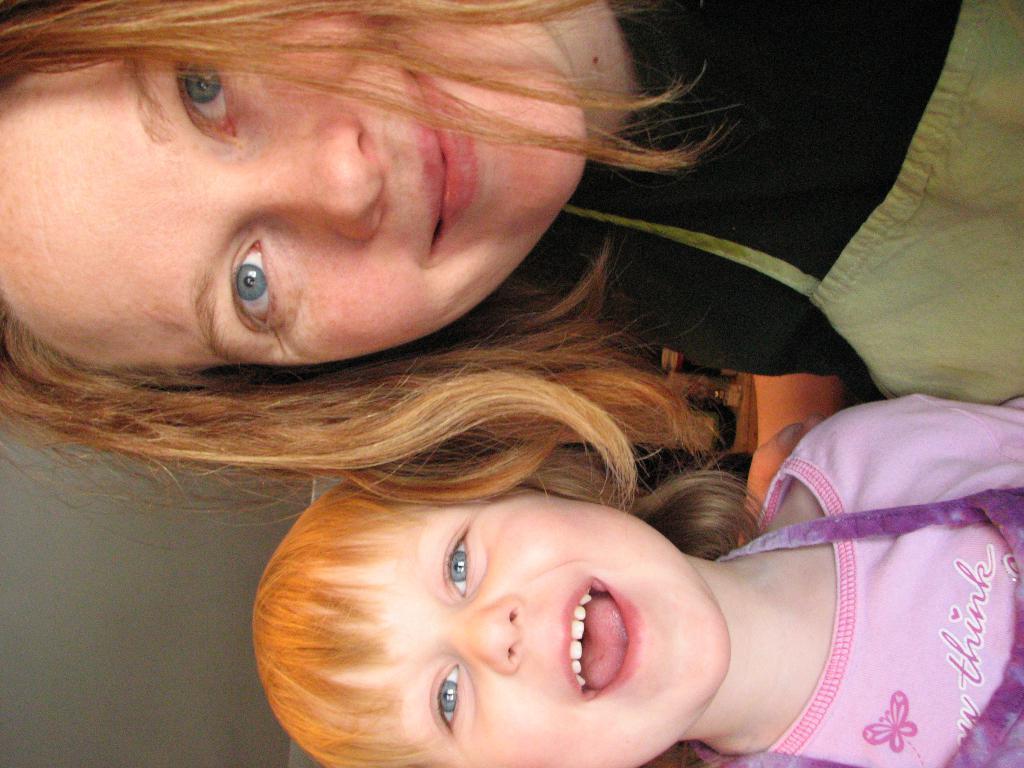How would you summarize this image in a sentence or two? In this image, we can see a person and kid wearing clothes. 